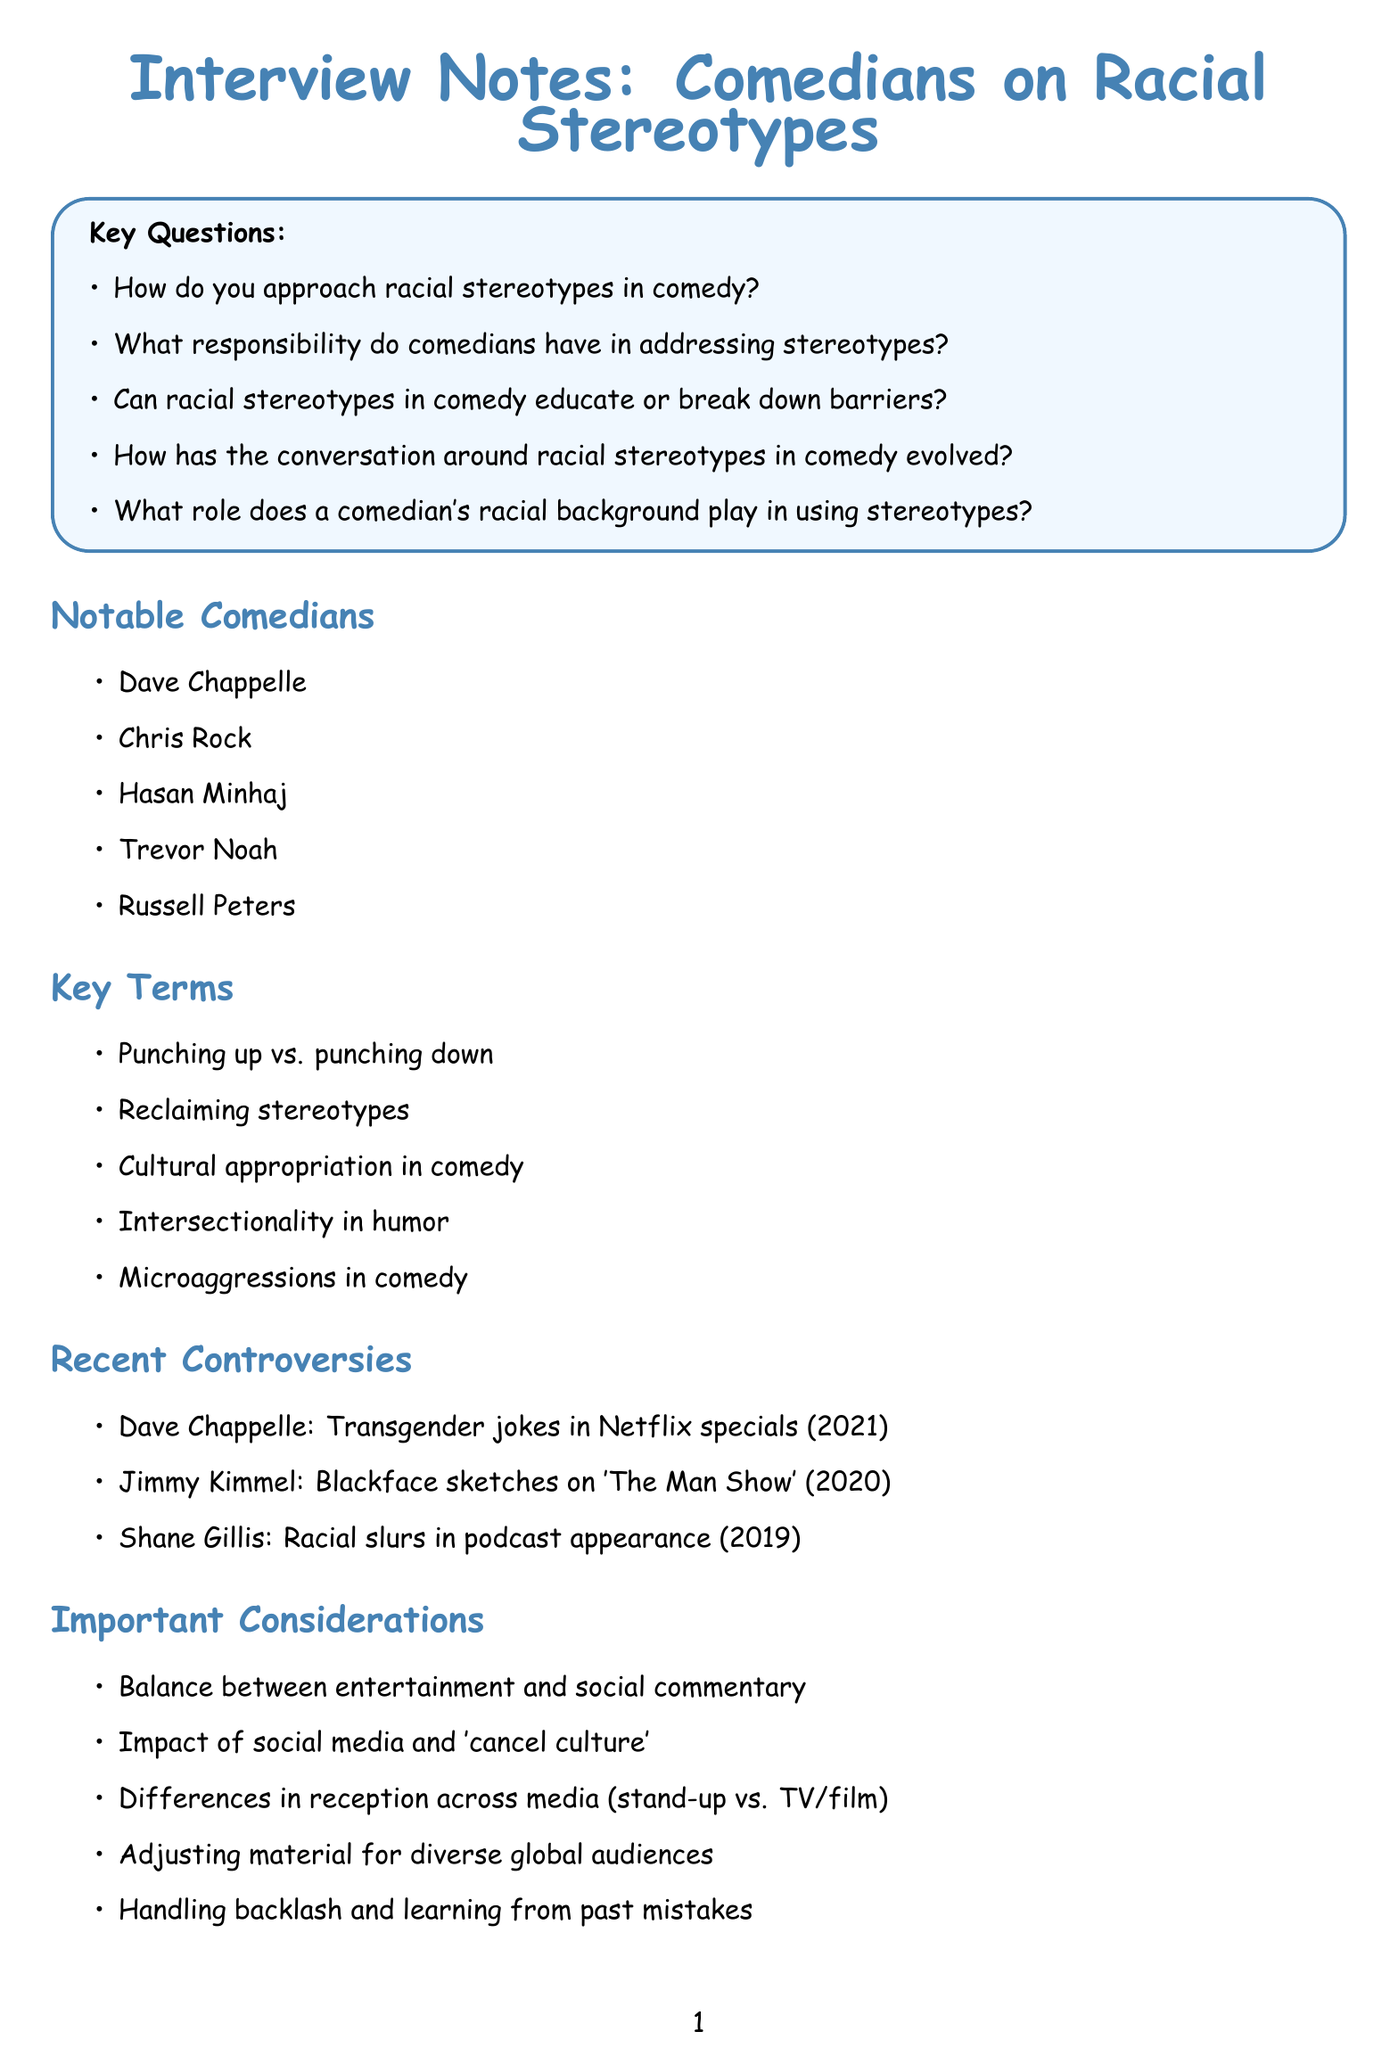What are the key questions about racial stereotypes in comedy? The key questions are listed in a section of the document, focusing on issues related to racial humor and responsibility.
Answer: How do you approach racial stereotypes in comedy? What responsibility do comedians have in addressing stereotypes? Can racial stereotypes in comedy educate or break down barriers? How has the conversation around racial stereotypes in comedy evolved? What role does a comedian's racial background play in using stereotypes? Who is a relevant comedian mentioned in the document? The document lists a number of comedians relevant to the discussion of racial stereotypes.
Answer: Dave Chappelle What year did Dave Chappelle face controversy for transgender jokes? The document specifies that this controversy occurred in 2021.
Answer: 2021 Name one key term related to racial stereotypes in comedy mentioned in the document. The document provides key terms that are essential for understanding the context of racial humor in comedy.
Answer: Punching up vs. punching down What is one important consideration for comedians dealing with racial stereotypes? The document outlines considerations that comedians must navigate in their work, including social context and audience reception.
Answer: Balance between entertainment and social commentary 